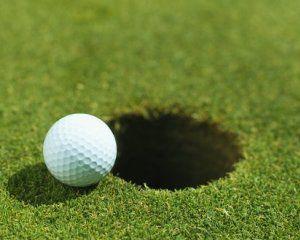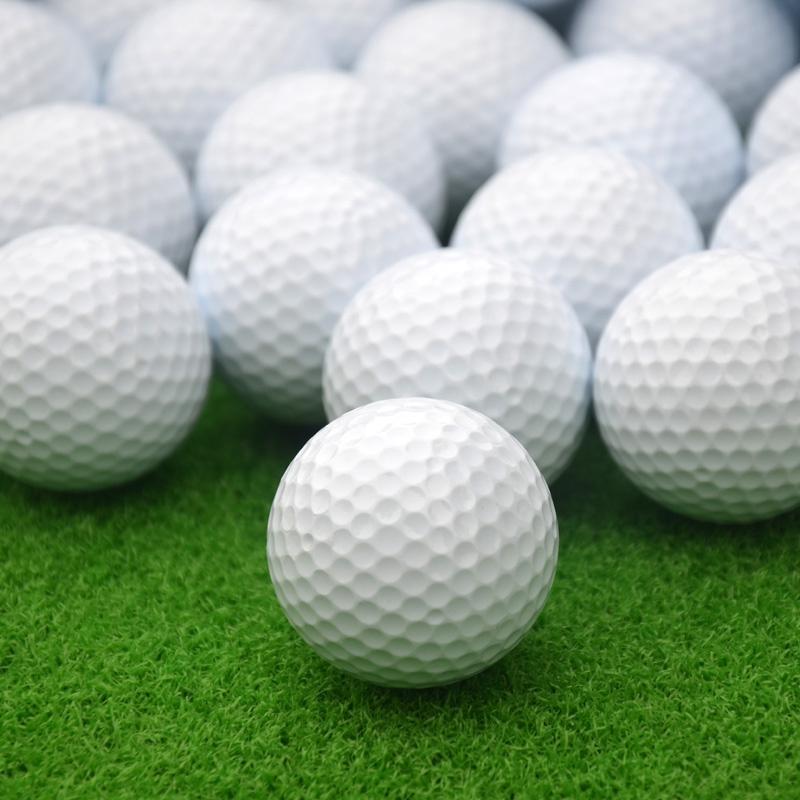The first image is the image on the left, the second image is the image on the right. For the images shown, is this caption "One image contains a mass of all-white balls on green turf, most with no space between them." true? Answer yes or no. Yes. The first image is the image on the left, the second image is the image on the right. Assess this claim about the two images: "There are exactly two golf balls in one of the images.". Correct or not? Answer yes or no. No. 